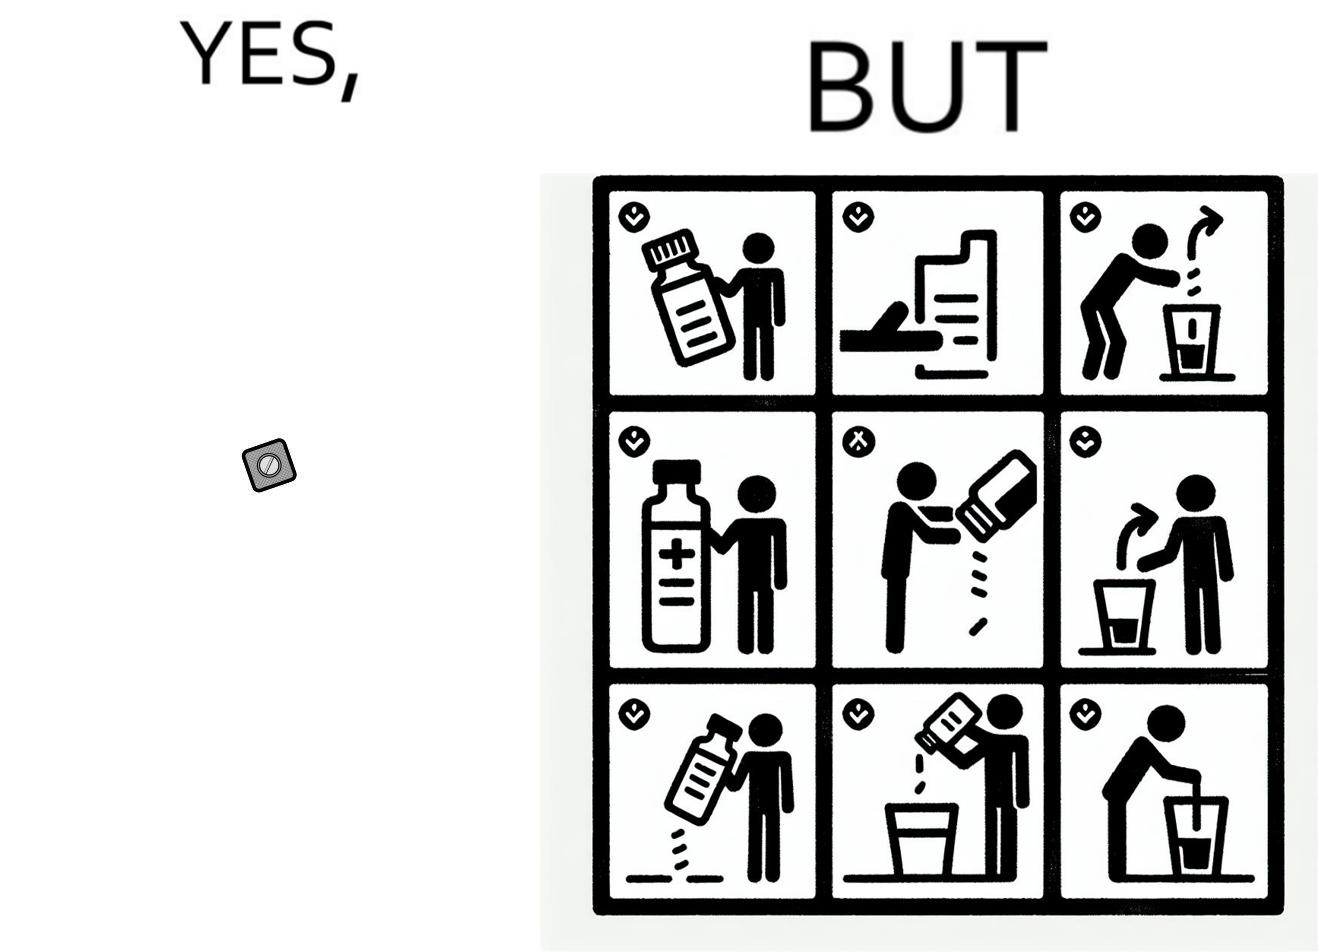Explain the humor or irony in this image. the irony in this image is a small thing like a medicine very often has instructions and a manual that is extremely long 